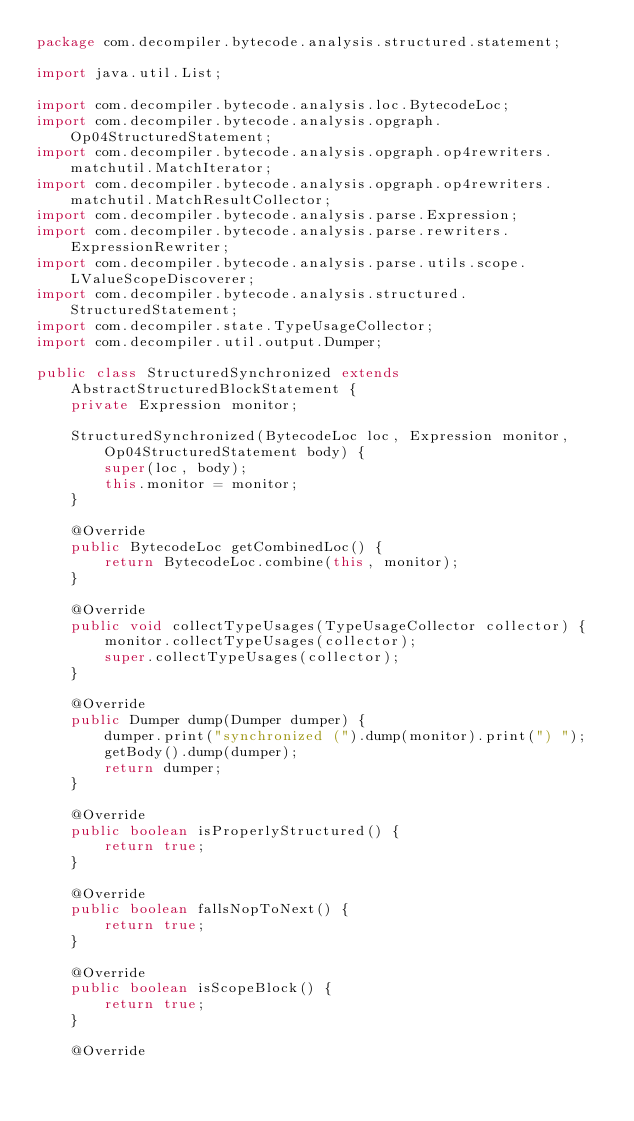<code> <loc_0><loc_0><loc_500><loc_500><_Java_>package com.decompiler.bytecode.analysis.structured.statement;

import java.util.List;

import com.decompiler.bytecode.analysis.loc.BytecodeLoc;
import com.decompiler.bytecode.analysis.opgraph.Op04StructuredStatement;
import com.decompiler.bytecode.analysis.opgraph.op4rewriters.matchutil.MatchIterator;
import com.decompiler.bytecode.analysis.opgraph.op4rewriters.matchutil.MatchResultCollector;
import com.decompiler.bytecode.analysis.parse.Expression;
import com.decompiler.bytecode.analysis.parse.rewriters.ExpressionRewriter;
import com.decompiler.bytecode.analysis.parse.utils.scope.LValueScopeDiscoverer;
import com.decompiler.bytecode.analysis.structured.StructuredStatement;
import com.decompiler.state.TypeUsageCollector;
import com.decompiler.util.output.Dumper;

public class StructuredSynchronized extends AbstractStructuredBlockStatement {
    private Expression monitor;

    StructuredSynchronized(BytecodeLoc loc, Expression monitor, Op04StructuredStatement body) {
        super(loc, body);
        this.monitor = monitor;
    }

    @Override
    public BytecodeLoc getCombinedLoc() {
        return BytecodeLoc.combine(this, monitor);
    }

    @Override
    public void collectTypeUsages(TypeUsageCollector collector) {
        monitor.collectTypeUsages(collector);
        super.collectTypeUsages(collector);
    }

    @Override
    public Dumper dump(Dumper dumper) {
        dumper.print("synchronized (").dump(monitor).print(") ");
        getBody().dump(dumper);
        return dumper;
    }

    @Override
    public boolean isProperlyStructured() {
        return true;
    }

    @Override
    public boolean fallsNopToNext() {
        return true;
    }

    @Override
    public boolean isScopeBlock() {
        return true;
    }

    @Override</code> 